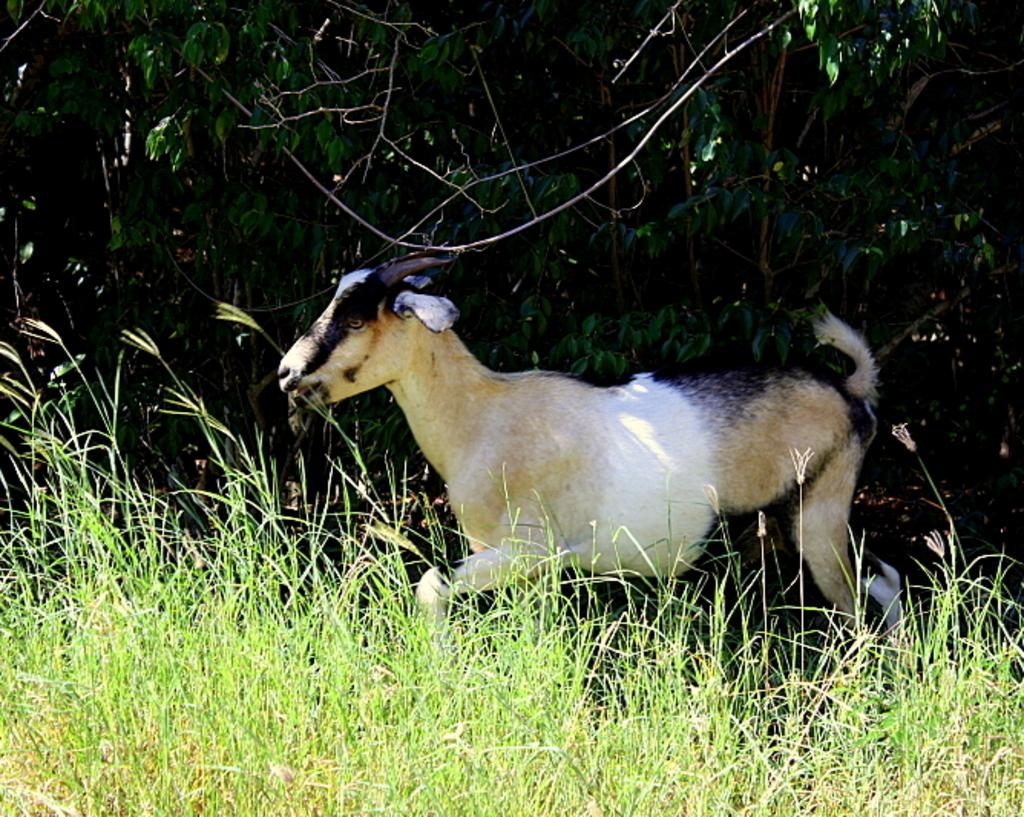What type of animal is in the image? The animal in the image has white, cream, and black colors. What is the color of the grass in the image? The grass in the image is green. What other natural elements can be seen in the image? There are trees in the image, and they are also green. What type of fire can be seen in the image? There is no fire present in the image. Is there a battle taking place in the image? There is no battle depicted in the image. 